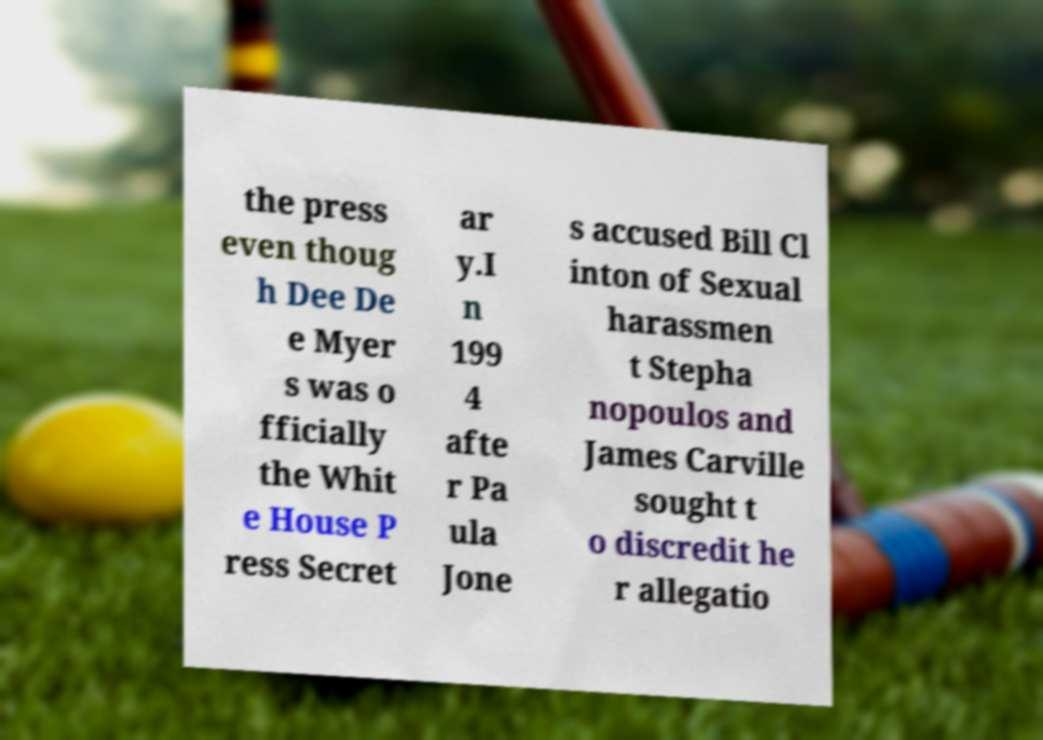Can you read and provide the text displayed in the image?This photo seems to have some interesting text. Can you extract and type it out for me? the press even thoug h Dee De e Myer s was o fficially the Whit e House P ress Secret ar y.I n 199 4 afte r Pa ula Jone s accused Bill Cl inton of Sexual harassmen t Stepha nopoulos and James Carville sought t o discredit he r allegatio 